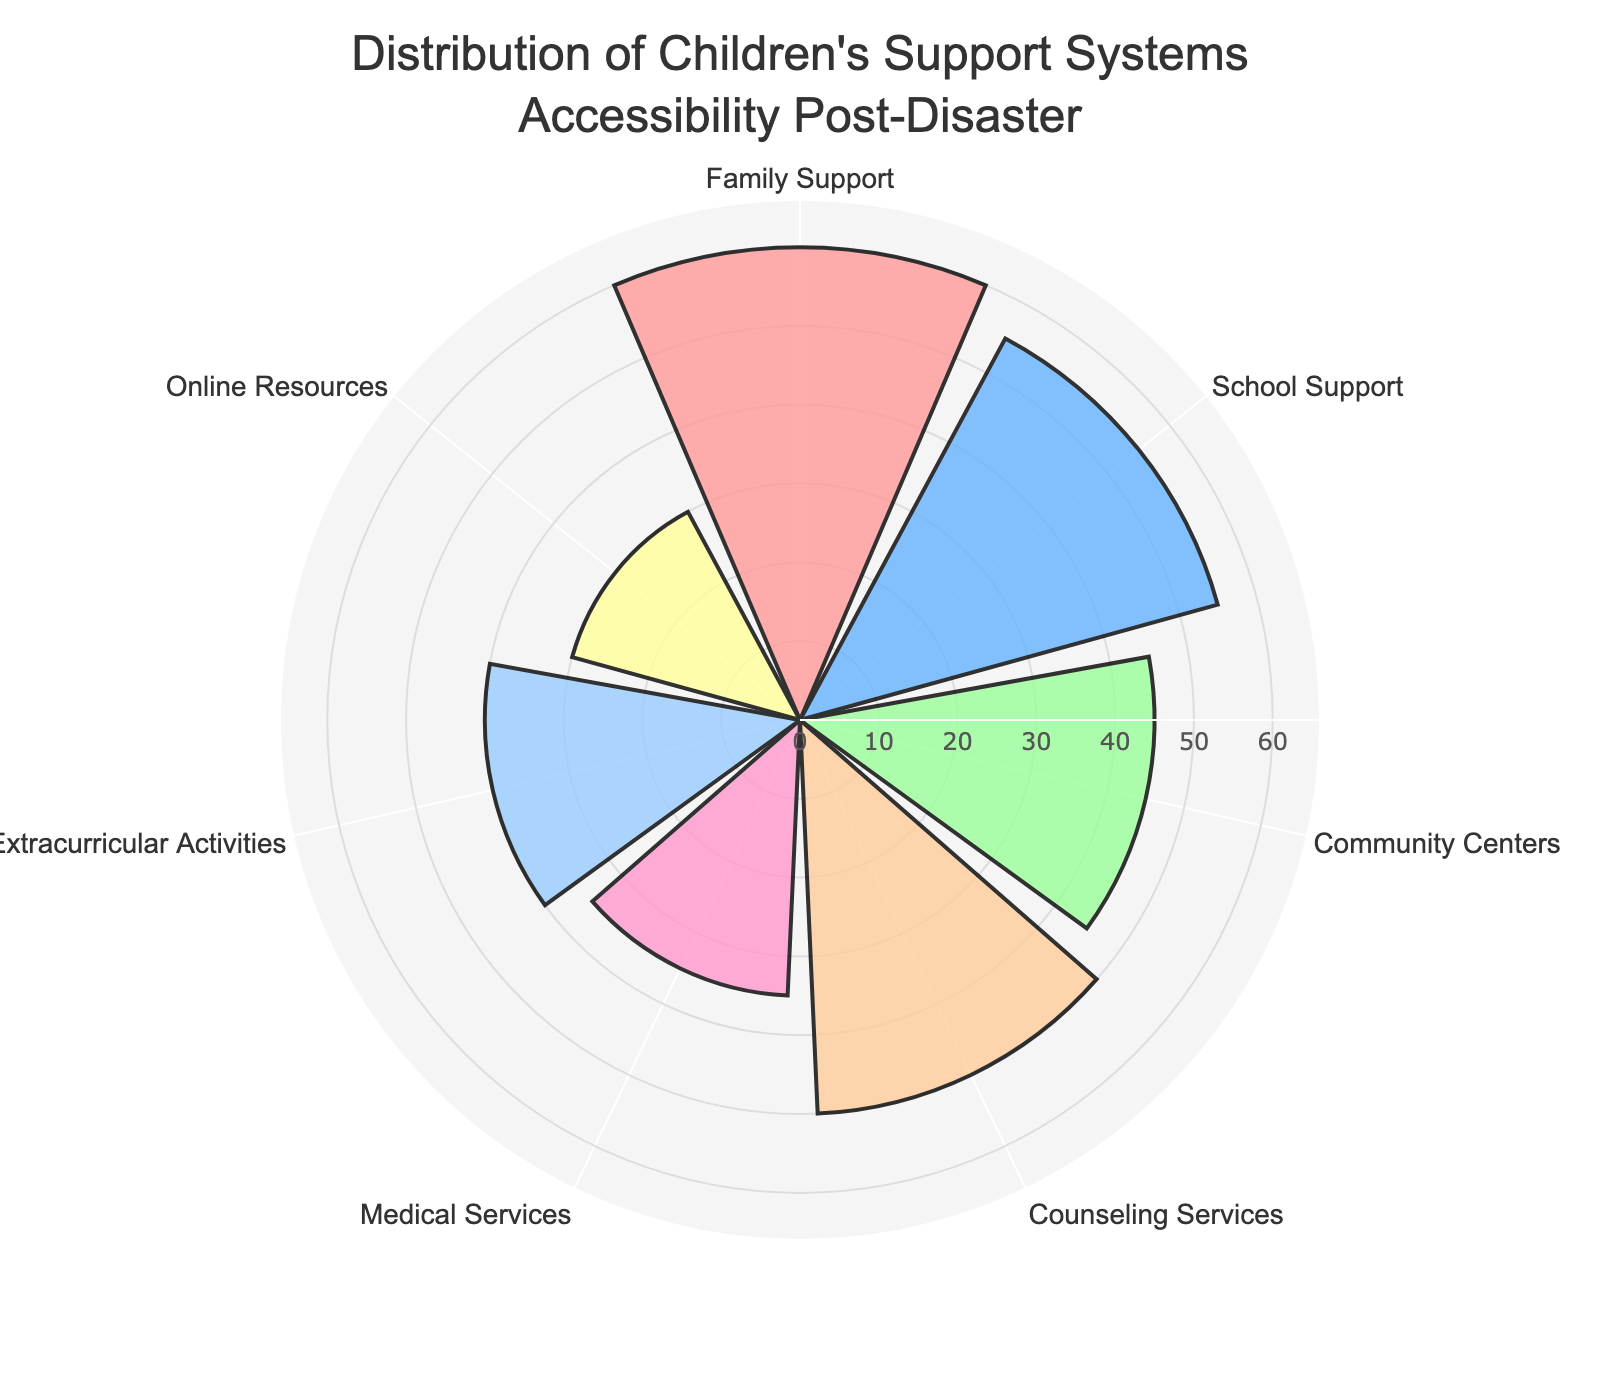What's the title of the figure? The title is usually displayed at the top of the figure and explicitly states what the chart represents.
Answer: Distribution of Children's Support Systems Accessibility Post-Disaster What category has the highest number of children served? Identify the segment with the longest radial length to find the category with the highest value.
Answer: Family Support Which category has the lowest number of children served? Identify the segment with the shortest radial length to find the category with the lowest value.
Answer: Online Resources What is the range of the radial axis? The range of the radial axis is specified in the layout of the chart, typically indicating the minimum and maximum values shown.
Answer: 0 to 66 How many children are served by Community Centers? Find the segment labeled "Community Centers" and refer to its radial length to determine the count.
Answer: 45 How many more children are served by Family Support compared to Counseling Services? Subtract the number of children served by Counseling Services from the number served by Family Support (60 - 50).
Answer: 10 Which two categories have the smallest difference in the number of children served? Compare the differences between the lengths of all pairs of segments and find the smallest one. The smallest difference is between Counseling Services (50) and School Support (55), which is 5.
Answer: Counseling Services and School Support How many categories have more than 40 children served? Count the number of segments with lengths greater than 40.
Answer: 4 What is the total number of children served across all categories? Sum the number of children served in all categories (60 + 55 + 45 + 50 + 35 + 40 + 30).
Answer: 315 Which category is served more: Medical Services or Extracurricular Activities? Compare the radial lengths of "Medical Services" and "Extracurricular Activities".
Answer: Extracurricular Activities 